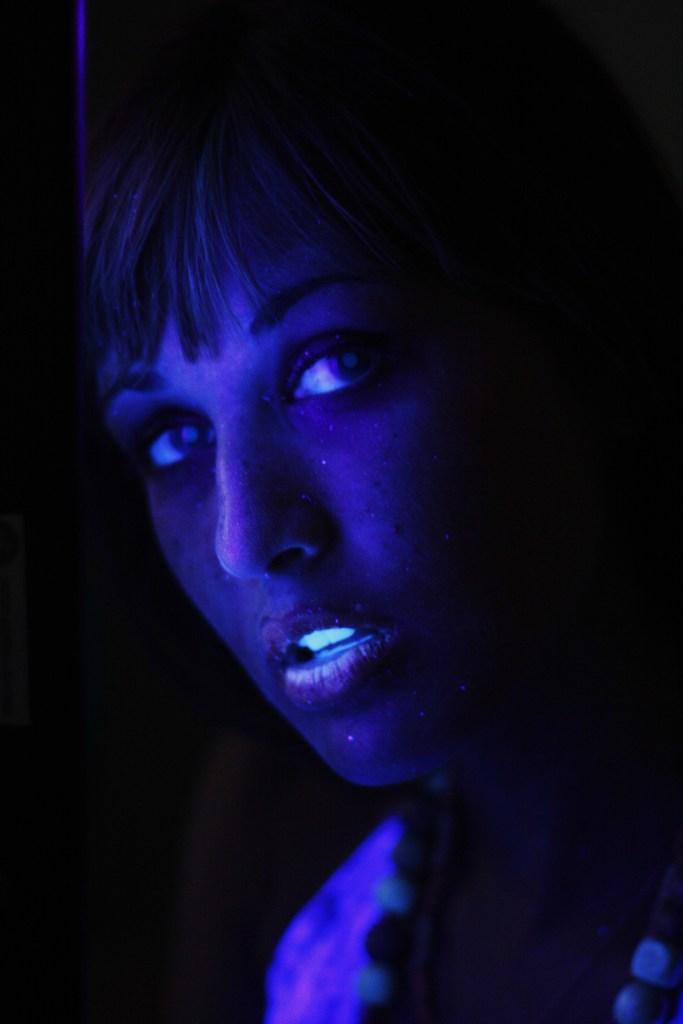Describe this image in one or two sentences. In this picture there is a woman who is painted her body with radium. On the left we can see the darkness. 